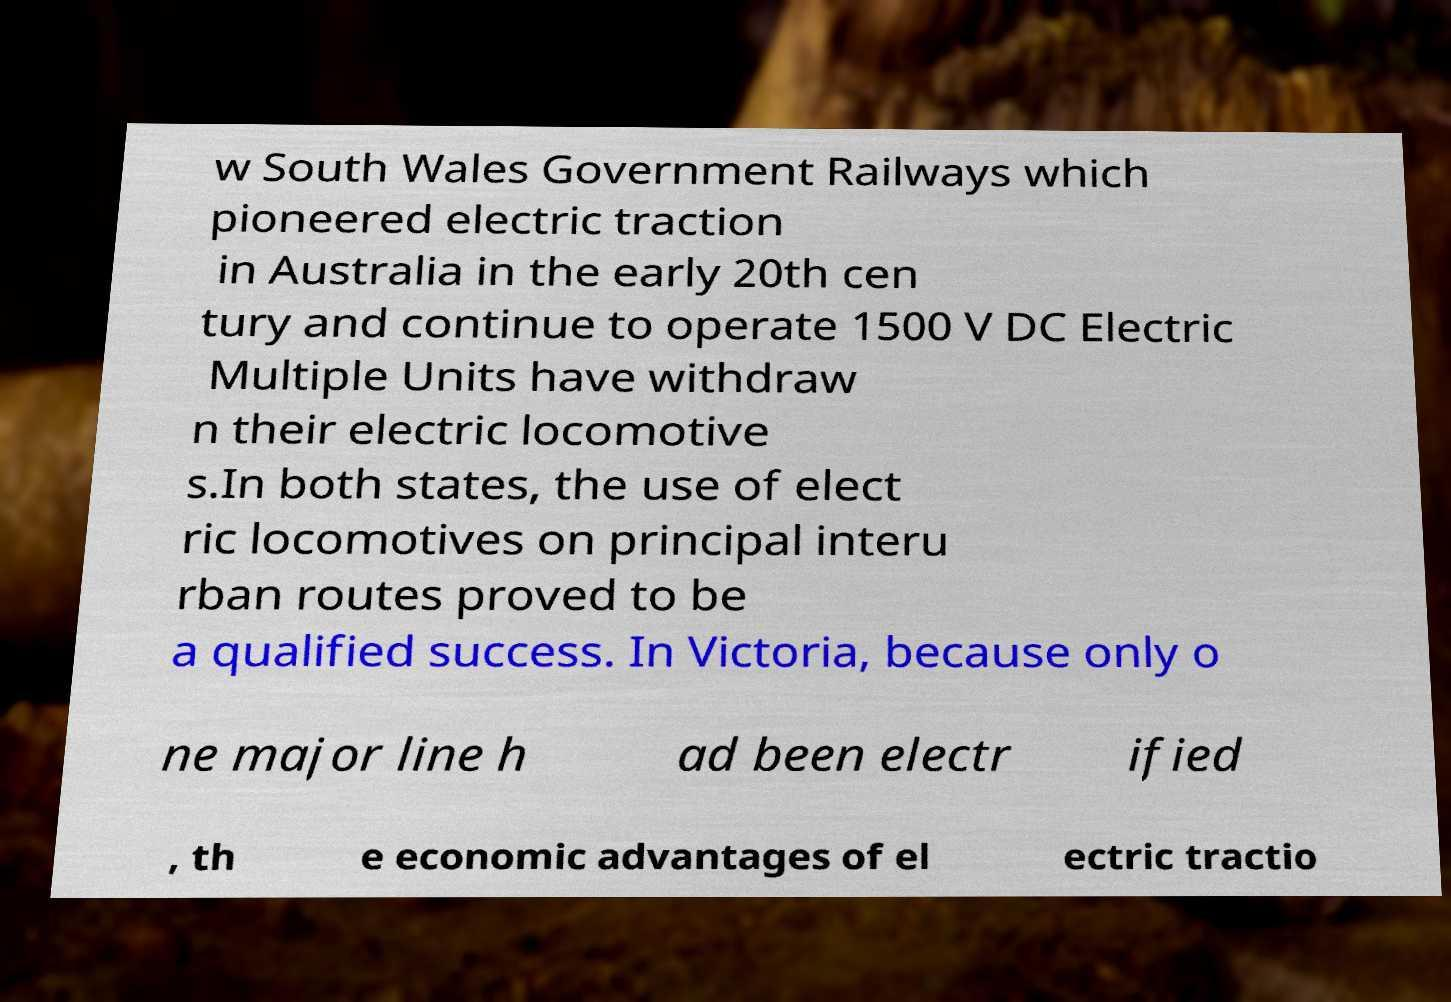I need the written content from this picture converted into text. Can you do that? w South Wales Government Railways which pioneered electric traction in Australia in the early 20th cen tury and continue to operate 1500 V DC Electric Multiple Units have withdraw n their electric locomotive s.In both states, the use of elect ric locomotives on principal interu rban routes proved to be a qualified success. In Victoria, because only o ne major line h ad been electr ified , th e economic advantages of el ectric tractio 